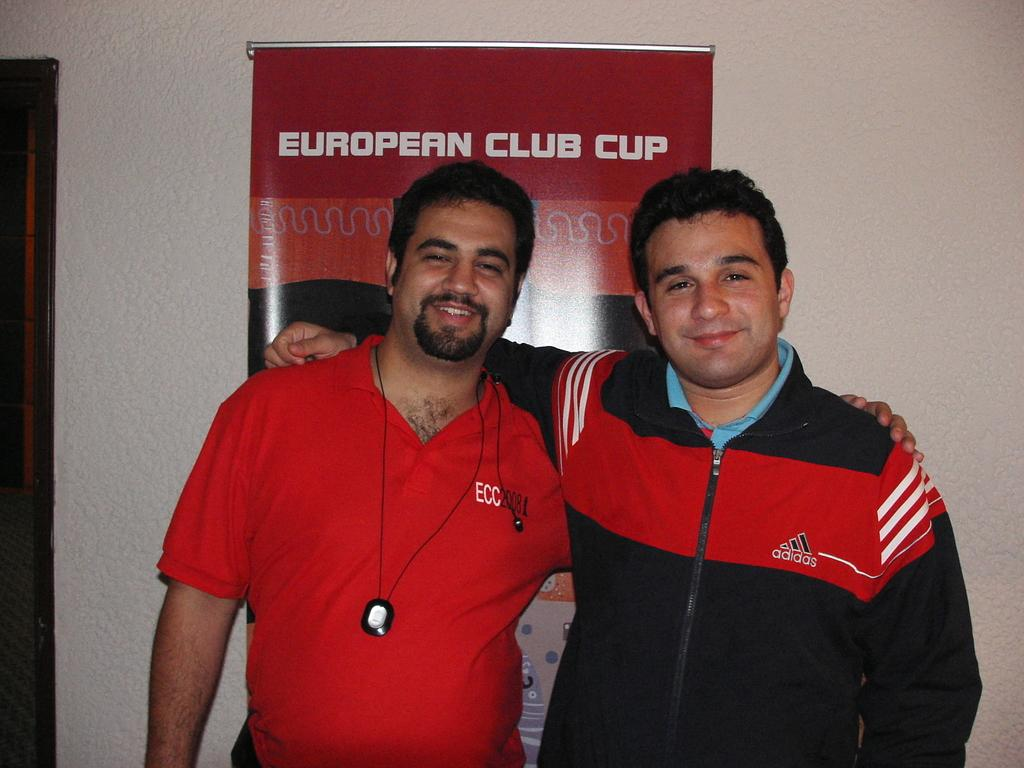<image>
Summarize the visual content of the image. Two men involved in sports pose for a picture in front of a red poster saying European Club Cup. 